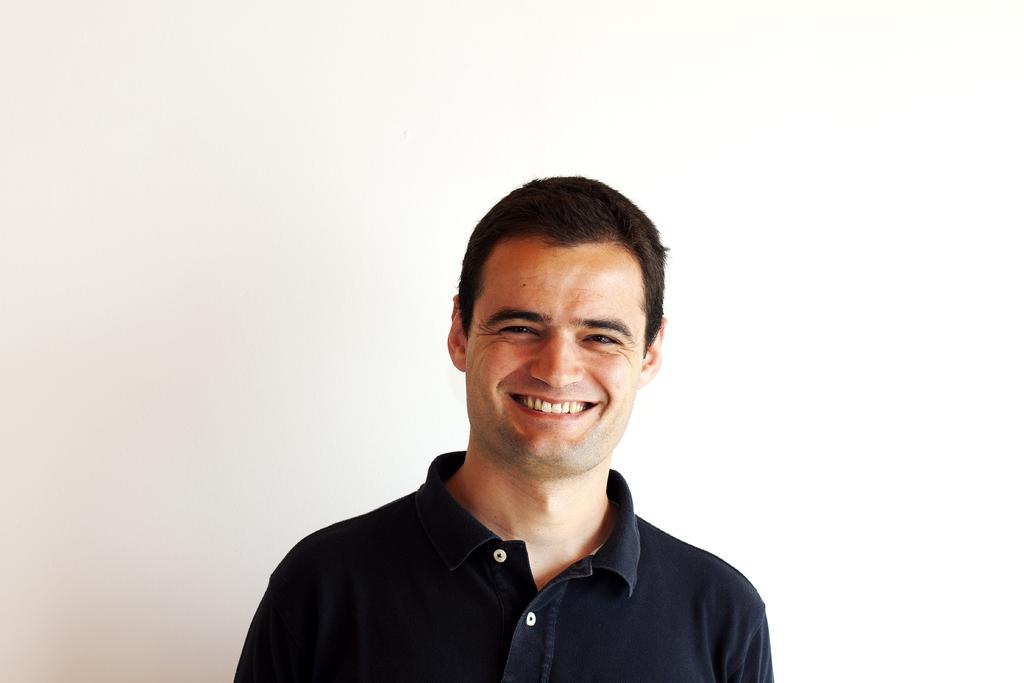What is the main subject of the image? There is a man in the image. What is the man doing in the image? The man is smiling. How many boys are present in the image? There is no boy present in the image; it features a man. What type of owl can be seen in the image? There is no owl present in the image. 